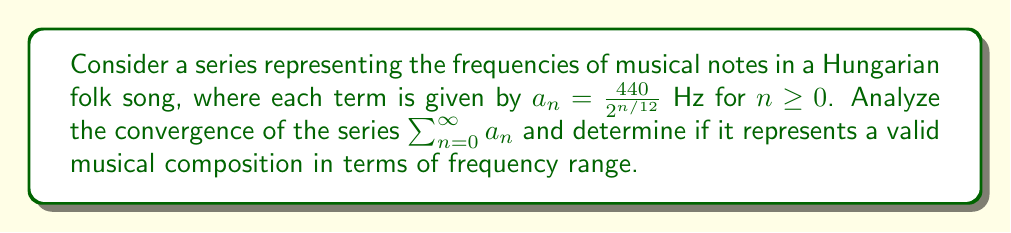Give your solution to this math problem. To analyze the convergence of this series, we'll follow these steps:

1) First, let's examine the general term $a_n = \frac{440}{2^{n/12}}$.

2) To test for convergence, we can use the ratio test:

   $\lim_{n \to \infty} |\frac{a_{n+1}}{a_n}| = \lim_{n \to \infty} \frac{\frac{440}{2^{(n+1)/12}}}{\frac{440}{2^{n/12}}}$

3) Simplify:
   
   $\lim_{n \to \infty} \frac{2^{n/12}}{2^{(n+1)/12}} = \lim_{n \to \infty} \frac{1}{2^{1/12}} \approx 0.9439$

4) Since this limit is less than 1, the series converges by the ratio test.

5) Now, let's consider the sum of this series:

   $S = \sum_{n=0}^{\infty} \frac{440}{2^{n/12}}$

6) This is a geometric series with first term $a = 440$ and common ratio $r = \frac{1}{2^{1/12}}$.

7) The sum of an infinite geometric series with $|r| < 1$ is given by $\frac{a}{1-r}$.

8) Therefore:

   $S = \frac{440}{1-\frac{1}{2^{1/12}}} \approx 8372.02$ Hz

9) In musical terms, this frequency is approximately C9, which is well above the range of human hearing (typically 20 Hz to 20,000 Hz) and most musical instruments.

10) However, each individual term in the series represents a valid musical frequency, starting from A4 (440 Hz) and descending chromatically.
Answer: The series $\sum_{n=0}^{\infty} \frac{440}{2^{n/12}}$ converges to approximately 8372.02 Hz. While the series itself converges mathematically, its sum represents a frequency beyond the range of human hearing and typical musical compositions. However, the individual terms of the series represent valid musical notes, making it a theoretically interesting but impractical musical construct. 